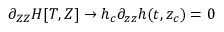Convert formula to latex. <formula><loc_0><loc_0><loc_500><loc_500>\partial _ { Z Z } H [ T , Z ] \to h _ { c } \partial _ { z z } h ( t , z _ { c } ) = 0</formula> 